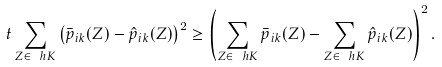Convert formula to latex. <formula><loc_0><loc_0><loc_500><loc_500>t \sum _ { Z \in \ h K } \left ( \bar { p } _ { i k } ( Z ) - \hat { p } _ { i k } ( Z ) \right ) ^ { 2 } \geq \left ( \sum _ { Z \in \ h K } \bar { p } _ { i k } ( Z ) - \sum _ { Z \in \ h K } \hat { p } _ { i k } ( Z ) \right ) ^ { 2 } .</formula> 